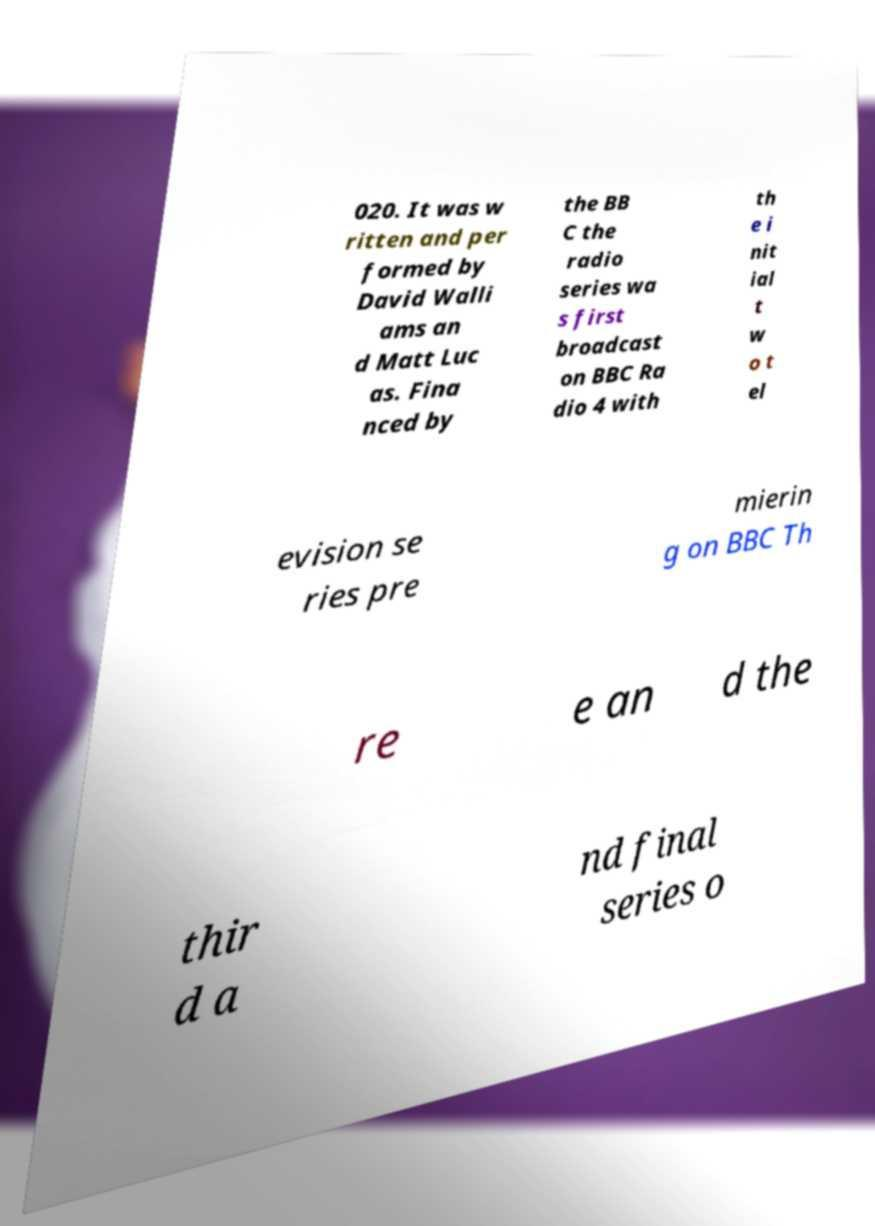I need the written content from this picture converted into text. Can you do that? 020. It was w ritten and per formed by David Walli ams an d Matt Luc as. Fina nced by the BB C the radio series wa s first broadcast on BBC Ra dio 4 with th e i nit ial t w o t el evision se ries pre mierin g on BBC Th re e an d the thir d a nd final series o 